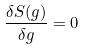Convert formula to latex. <formula><loc_0><loc_0><loc_500><loc_500>\frac { \delta S ( g ) } { \delta g } = 0</formula> 